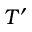<formula> <loc_0><loc_0><loc_500><loc_500>T ^ { \prime }</formula> 